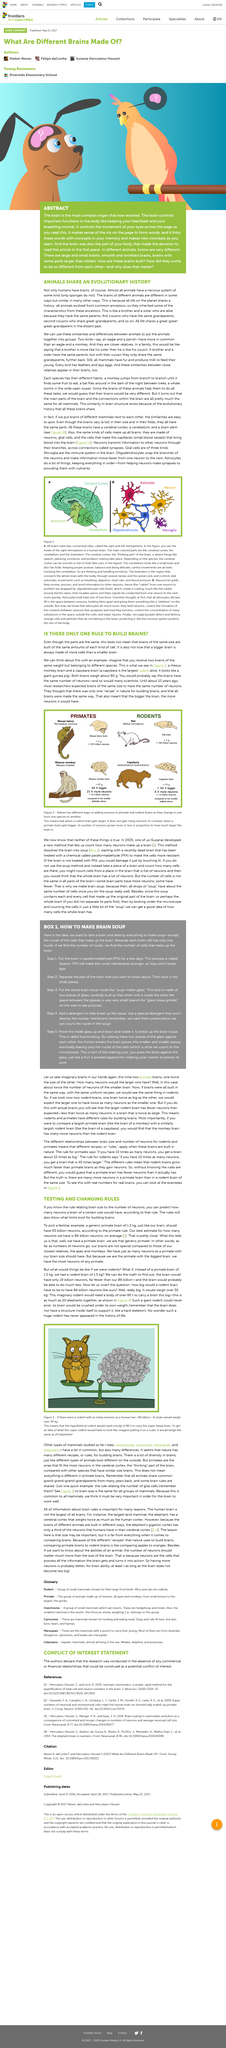Highlight a few significant elements in this photo. The Rhesus monkey is also known as Macaca mulatta, and its scientific name is Macaca mulatta. Mammalian brains, despite their differences in size and the presence of folds, share a fundamental similarity in terms of their overall structure and organization. It is a myth that a larger brain necessarily contains more cells than a smaller brain. According to the primate rule, it is estimated that our brain should have approximately 93 billion neurons. It is estimated that the average human brain contains approximately 86 billion neurons. 